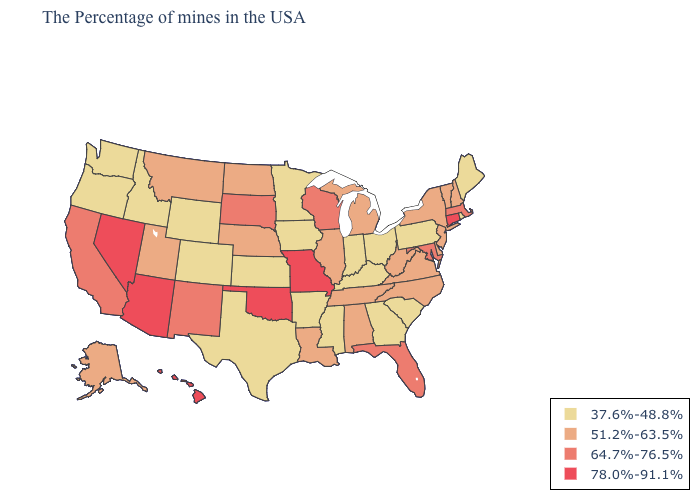Which states have the lowest value in the USA?
Give a very brief answer. Maine, Rhode Island, Pennsylvania, South Carolina, Ohio, Georgia, Kentucky, Indiana, Mississippi, Arkansas, Minnesota, Iowa, Kansas, Texas, Wyoming, Colorado, Idaho, Washington, Oregon. What is the lowest value in the USA?
Short answer required. 37.6%-48.8%. What is the value of Arkansas?
Be succinct. 37.6%-48.8%. Does the first symbol in the legend represent the smallest category?
Concise answer only. Yes. Name the states that have a value in the range 78.0%-91.1%?
Short answer required. Connecticut, Missouri, Oklahoma, Arizona, Nevada, Hawaii. What is the lowest value in the South?
Quick response, please. 37.6%-48.8%. Which states have the highest value in the USA?
Keep it brief. Connecticut, Missouri, Oklahoma, Arizona, Nevada, Hawaii. Does New Hampshire have the same value as Rhode Island?
Be succinct. No. What is the value of New Mexico?
Short answer required. 64.7%-76.5%. Name the states that have a value in the range 37.6%-48.8%?
Write a very short answer. Maine, Rhode Island, Pennsylvania, South Carolina, Ohio, Georgia, Kentucky, Indiana, Mississippi, Arkansas, Minnesota, Iowa, Kansas, Texas, Wyoming, Colorado, Idaho, Washington, Oregon. What is the highest value in the USA?
Be succinct. 78.0%-91.1%. Which states hav the highest value in the South?
Concise answer only. Oklahoma. What is the lowest value in the West?
Answer briefly. 37.6%-48.8%. Name the states that have a value in the range 78.0%-91.1%?
Write a very short answer. Connecticut, Missouri, Oklahoma, Arizona, Nevada, Hawaii. What is the highest value in the USA?
Keep it brief. 78.0%-91.1%. 